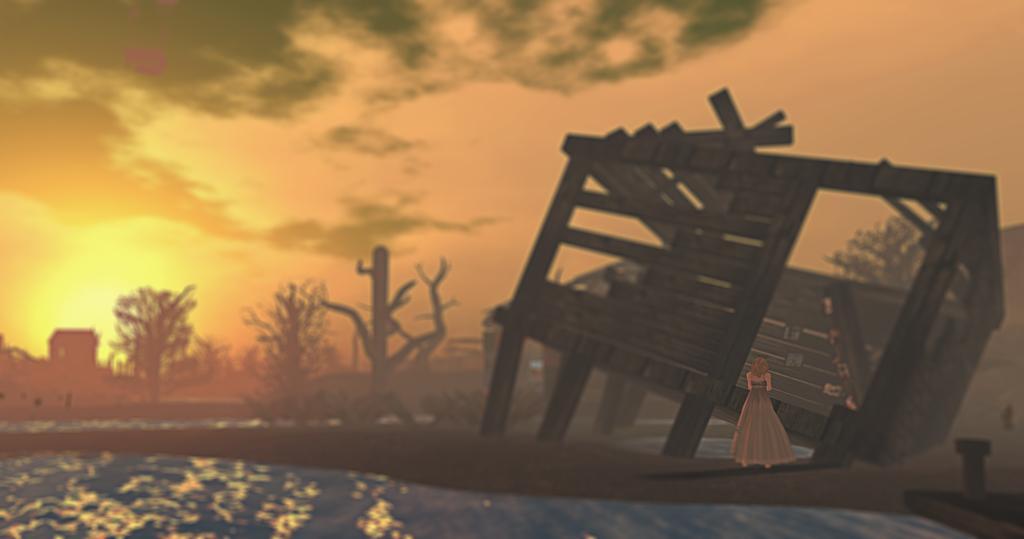In one or two sentences, can you explain what this image depicts? This is an animated picture where I can see a collapsed house, a person standing, trees and there is sky. 